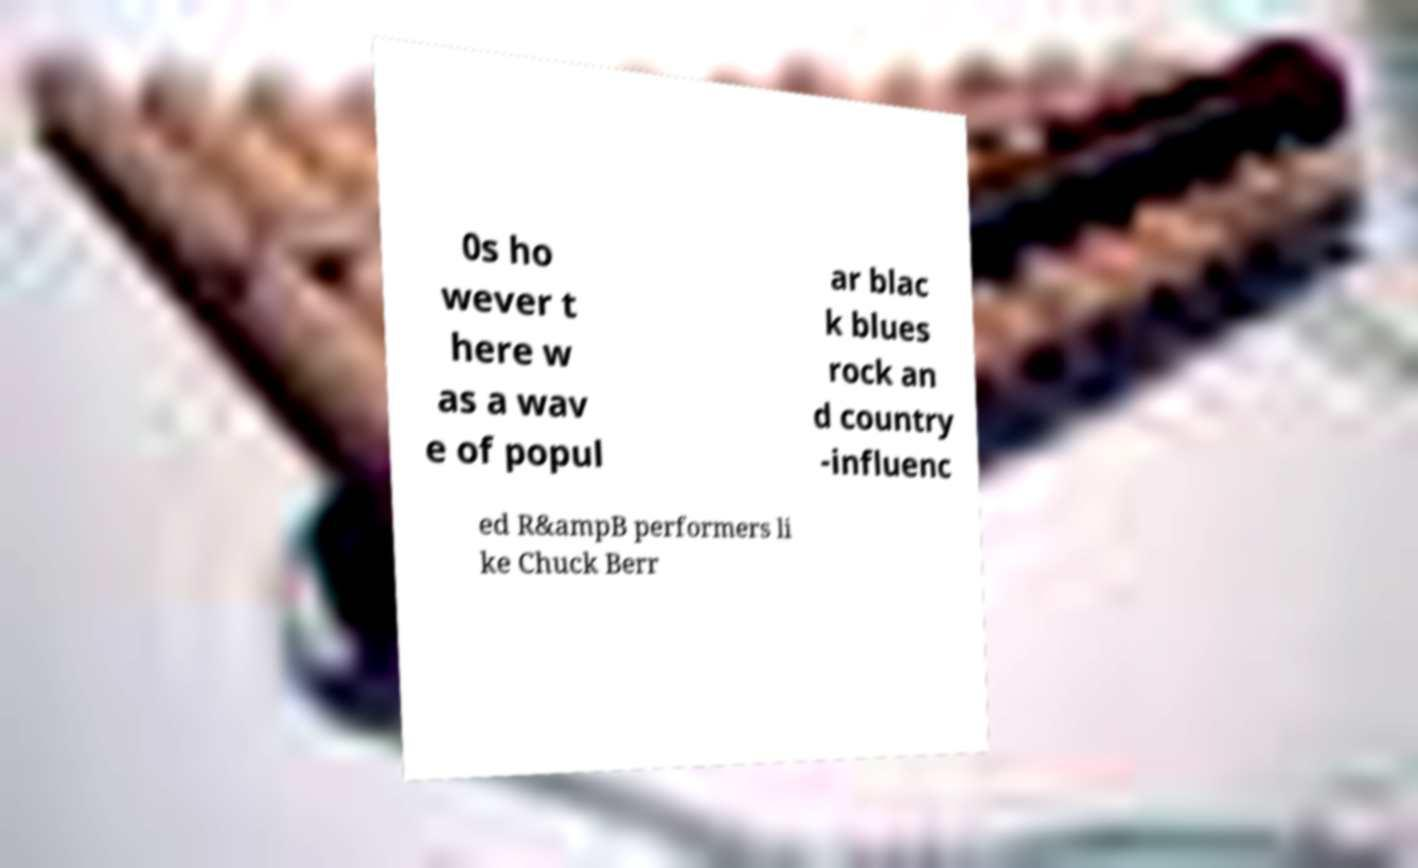For documentation purposes, I need the text within this image transcribed. Could you provide that? 0s ho wever t here w as a wav e of popul ar blac k blues rock an d country -influenc ed R&ampB performers li ke Chuck Berr 